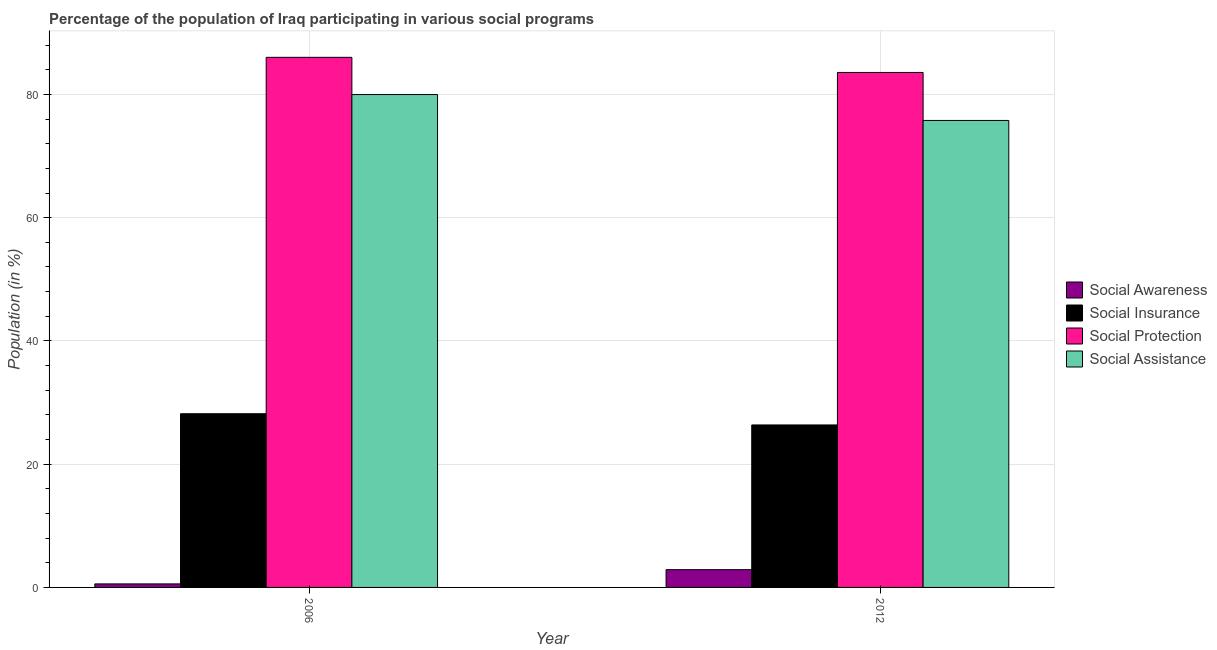How many groups of bars are there?
Make the answer very short. 2. Are the number of bars per tick equal to the number of legend labels?
Keep it short and to the point. Yes. How many bars are there on the 2nd tick from the left?
Your answer should be very brief. 4. What is the label of the 1st group of bars from the left?
Offer a very short reply. 2006. What is the participation of population in social awareness programs in 2006?
Keep it short and to the point. 0.57. Across all years, what is the maximum participation of population in social awareness programs?
Give a very brief answer. 2.88. Across all years, what is the minimum participation of population in social protection programs?
Ensure brevity in your answer.  83.56. In which year was the participation of population in social awareness programs maximum?
Provide a succinct answer. 2012. What is the total participation of population in social insurance programs in the graph?
Keep it short and to the point. 54.55. What is the difference between the participation of population in social assistance programs in 2006 and that in 2012?
Ensure brevity in your answer.  4.2. What is the difference between the participation of population in social protection programs in 2012 and the participation of population in social assistance programs in 2006?
Ensure brevity in your answer.  -2.45. What is the average participation of population in social awareness programs per year?
Ensure brevity in your answer.  1.73. In how many years, is the participation of population in social protection programs greater than 24 %?
Provide a short and direct response. 2. What is the ratio of the participation of population in social insurance programs in 2006 to that in 2012?
Provide a succinct answer. 1.07. In how many years, is the participation of population in social insurance programs greater than the average participation of population in social insurance programs taken over all years?
Your response must be concise. 1. What does the 2nd bar from the left in 2006 represents?
Your response must be concise. Social Insurance. What does the 3rd bar from the right in 2006 represents?
Provide a succinct answer. Social Insurance. Is it the case that in every year, the sum of the participation of population in social awareness programs and participation of population in social insurance programs is greater than the participation of population in social protection programs?
Give a very brief answer. No. How many bars are there?
Your answer should be compact. 8. Are all the bars in the graph horizontal?
Keep it short and to the point. No. What is the difference between two consecutive major ticks on the Y-axis?
Your answer should be very brief. 20. Where does the legend appear in the graph?
Make the answer very short. Center right. What is the title of the graph?
Give a very brief answer. Percentage of the population of Iraq participating in various social programs . Does "Overall level" appear as one of the legend labels in the graph?
Your answer should be compact. No. What is the label or title of the X-axis?
Make the answer very short. Year. What is the Population (in %) of Social Awareness in 2006?
Ensure brevity in your answer.  0.57. What is the Population (in %) in Social Insurance in 2006?
Your answer should be very brief. 28.19. What is the Population (in %) of Social Protection in 2006?
Make the answer very short. 86.01. What is the Population (in %) of Social Assistance in 2006?
Your answer should be very brief. 79.97. What is the Population (in %) in Social Awareness in 2012?
Keep it short and to the point. 2.88. What is the Population (in %) of Social Insurance in 2012?
Your response must be concise. 26.36. What is the Population (in %) in Social Protection in 2012?
Provide a succinct answer. 83.56. What is the Population (in %) in Social Assistance in 2012?
Provide a succinct answer. 75.77. Across all years, what is the maximum Population (in %) of Social Awareness?
Offer a very short reply. 2.88. Across all years, what is the maximum Population (in %) in Social Insurance?
Your answer should be very brief. 28.19. Across all years, what is the maximum Population (in %) in Social Protection?
Provide a succinct answer. 86.01. Across all years, what is the maximum Population (in %) of Social Assistance?
Ensure brevity in your answer.  79.97. Across all years, what is the minimum Population (in %) in Social Awareness?
Your answer should be very brief. 0.57. Across all years, what is the minimum Population (in %) in Social Insurance?
Provide a succinct answer. 26.36. Across all years, what is the minimum Population (in %) in Social Protection?
Your response must be concise. 83.56. Across all years, what is the minimum Population (in %) of Social Assistance?
Your answer should be compact. 75.77. What is the total Population (in %) of Social Awareness in the graph?
Ensure brevity in your answer.  3.45. What is the total Population (in %) in Social Insurance in the graph?
Provide a succinct answer. 54.55. What is the total Population (in %) in Social Protection in the graph?
Keep it short and to the point. 169.57. What is the total Population (in %) of Social Assistance in the graph?
Provide a succinct answer. 155.75. What is the difference between the Population (in %) of Social Awareness in 2006 and that in 2012?
Make the answer very short. -2.31. What is the difference between the Population (in %) of Social Insurance in 2006 and that in 2012?
Offer a terse response. 1.82. What is the difference between the Population (in %) of Social Protection in 2006 and that in 2012?
Keep it short and to the point. 2.45. What is the difference between the Population (in %) in Social Assistance in 2006 and that in 2012?
Make the answer very short. 4.2. What is the difference between the Population (in %) of Social Awareness in 2006 and the Population (in %) of Social Insurance in 2012?
Your response must be concise. -25.79. What is the difference between the Population (in %) in Social Awareness in 2006 and the Population (in %) in Social Protection in 2012?
Your answer should be very brief. -82.99. What is the difference between the Population (in %) of Social Awareness in 2006 and the Population (in %) of Social Assistance in 2012?
Your response must be concise. -75.2. What is the difference between the Population (in %) in Social Insurance in 2006 and the Population (in %) in Social Protection in 2012?
Provide a succinct answer. -55.37. What is the difference between the Population (in %) in Social Insurance in 2006 and the Population (in %) in Social Assistance in 2012?
Provide a short and direct response. -47.59. What is the difference between the Population (in %) of Social Protection in 2006 and the Population (in %) of Social Assistance in 2012?
Ensure brevity in your answer.  10.24. What is the average Population (in %) of Social Awareness per year?
Provide a short and direct response. 1.73. What is the average Population (in %) in Social Insurance per year?
Provide a short and direct response. 27.27. What is the average Population (in %) of Social Protection per year?
Your answer should be compact. 84.79. What is the average Population (in %) of Social Assistance per year?
Provide a short and direct response. 77.87. In the year 2006, what is the difference between the Population (in %) of Social Awareness and Population (in %) of Social Insurance?
Ensure brevity in your answer.  -27.61. In the year 2006, what is the difference between the Population (in %) of Social Awareness and Population (in %) of Social Protection?
Keep it short and to the point. -85.44. In the year 2006, what is the difference between the Population (in %) of Social Awareness and Population (in %) of Social Assistance?
Your answer should be very brief. -79.4. In the year 2006, what is the difference between the Population (in %) in Social Insurance and Population (in %) in Social Protection?
Keep it short and to the point. -57.83. In the year 2006, what is the difference between the Population (in %) of Social Insurance and Population (in %) of Social Assistance?
Your answer should be very brief. -51.79. In the year 2006, what is the difference between the Population (in %) of Social Protection and Population (in %) of Social Assistance?
Provide a short and direct response. 6.04. In the year 2012, what is the difference between the Population (in %) in Social Awareness and Population (in %) in Social Insurance?
Your answer should be compact. -23.48. In the year 2012, what is the difference between the Population (in %) in Social Awareness and Population (in %) in Social Protection?
Provide a succinct answer. -80.68. In the year 2012, what is the difference between the Population (in %) of Social Awareness and Population (in %) of Social Assistance?
Offer a terse response. -72.89. In the year 2012, what is the difference between the Population (in %) of Social Insurance and Population (in %) of Social Protection?
Your response must be concise. -57.2. In the year 2012, what is the difference between the Population (in %) in Social Insurance and Population (in %) in Social Assistance?
Offer a terse response. -49.41. In the year 2012, what is the difference between the Population (in %) of Social Protection and Population (in %) of Social Assistance?
Your answer should be compact. 7.79. What is the ratio of the Population (in %) in Social Awareness in 2006 to that in 2012?
Make the answer very short. 0.2. What is the ratio of the Population (in %) in Social Insurance in 2006 to that in 2012?
Give a very brief answer. 1.07. What is the ratio of the Population (in %) of Social Protection in 2006 to that in 2012?
Make the answer very short. 1.03. What is the ratio of the Population (in %) in Social Assistance in 2006 to that in 2012?
Provide a succinct answer. 1.06. What is the difference between the highest and the second highest Population (in %) in Social Awareness?
Your answer should be very brief. 2.31. What is the difference between the highest and the second highest Population (in %) of Social Insurance?
Give a very brief answer. 1.82. What is the difference between the highest and the second highest Population (in %) in Social Protection?
Offer a terse response. 2.45. What is the difference between the highest and the second highest Population (in %) in Social Assistance?
Keep it short and to the point. 4.2. What is the difference between the highest and the lowest Population (in %) of Social Awareness?
Offer a very short reply. 2.31. What is the difference between the highest and the lowest Population (in %) in Social Insurance?
Keep it short and to the point. 1.82. What is the difference between the highest and the lowest Population (in %) in Social Protection?
Offer a very short reply. 2.45. What is the difference between the highest and the lowest Population (in %) of Social Assistance?
Offer a terse response. 4.2. 